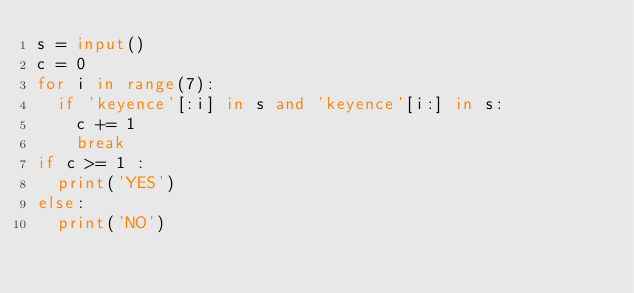Convert code to text. <code><loc_0><loc_0><loc_500><loc_500><_Python_>s = input()
c = 0
for i in range(7):
  if 'keyence'[:i] in s and 'keyence'[i:] in s:
    c += 1
    break
if c >= 1 :
  print('YES')
else:
  print('NO')</code> 